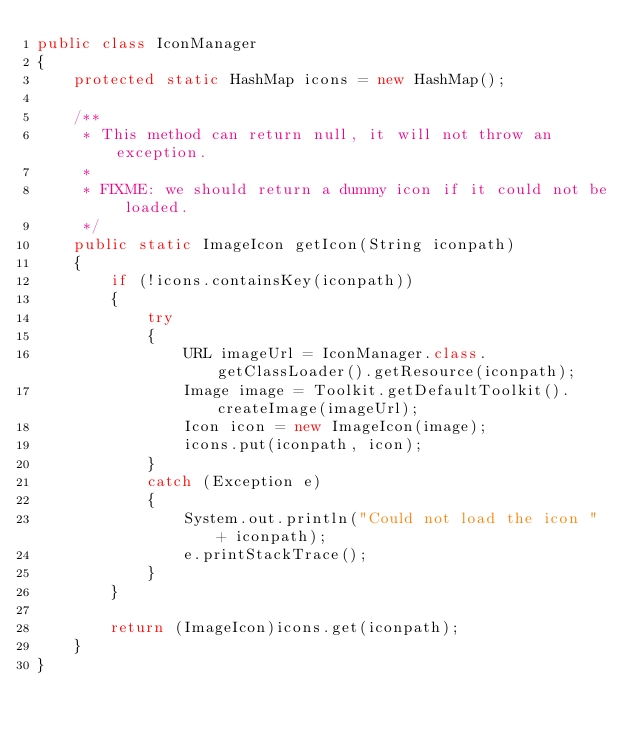Convert code to text. <code><loc_0><loc_0><loc_500><loc_500><_Java_>public class IconManager
{
    protected static HashMap icons = new HashMap();

    /**
     * This method can return null, it will not throw an exception.
     *
     * FIXME: we should return a dummy icon if it could not be loaded.
     */
    public static ImageIcon getIcon(String iconpath)
    {
        if (!icons.containsKey(iconpath))
        {
            try
            {
                URL imageUrl = IconManager.class.getClassLoader().getResource(iconpath);
                Image image = Toolkit.getDefaultToolkit().createImage(imageUrl);
                Icon icon = new ImageIcon(image);
                icons.put(iconpath, icon);
            }
            catch (Exception e)
            {
                System.out.println("Could not load the icon " + iconpath);
                e.printStackTrace();
            }
        }

        return (ImageIcon)icons.get(iconpath);
    }
}
</code> 